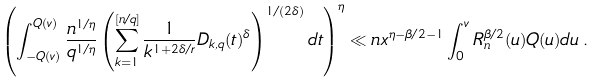<formula> <loc_0><loc_0><loc_500><loc_500>\left ( \int _ { - Q ( v ) } ^ { Q ( v ) } \frac { n ^ { 1 / \eta } } { q ^ { 1 / \eta } } \left ( \sum _ { k = 1 } ^ { [ n / q ] } \frac { 1 } { k ^ { 1 + 2 \delta / r } } D _ { k , q } ( t ) ^ { \delta } \right ) ^ { 1 / ( 2 \delta ) } d t \right ) ^ { \eta } \ll n x ^ { \eta - \beta / 2 - 1 } \int _ { 0 } ^ { v } R _ { n } ^ { \beta / 2 } ( u ) Q ( u ) d u \, .</formula> 